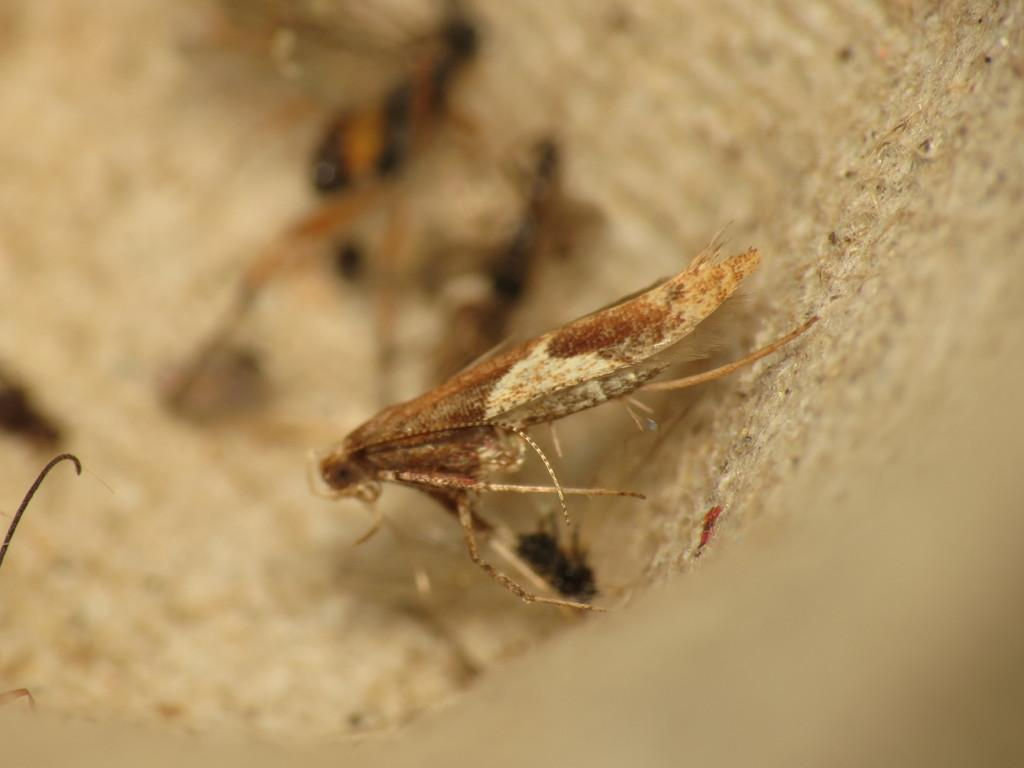What type of creature can be seen in the image? There is an insect in the image. What color is the insect? The insect is brown in color. Can you describe the background of the image? The background of the image is blurred. Is the horse in the image walking towards the train? There is no horse or train present in the image; it features an insect with a blurred background. 